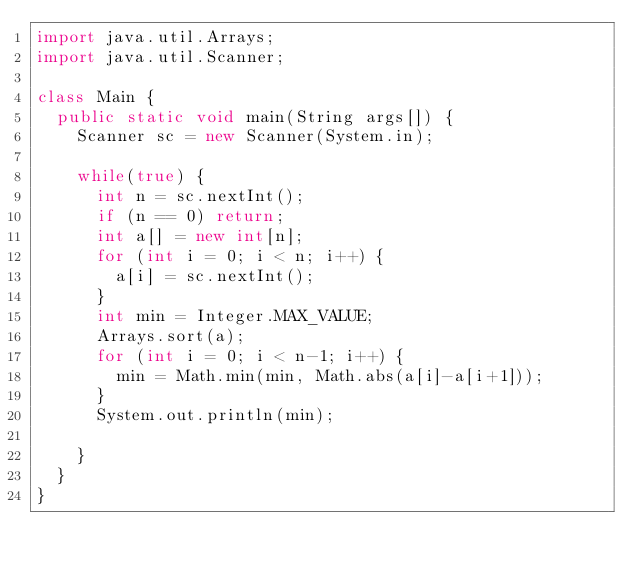<code> <loc_0><loc_0><loc_500><loc_500><_Java_>import java.util.Arrays;
import java.util.Scanner;

class Main {
	public static void main(String args[]) {
		Scanner sc = new Scanner(System.in);

		while(true) {
			int n = sc.nextInt();
			if (n == 0) return;
			int a[] = new int[n];
			for (int i = 0; i < n; i++) {
				a[i] = sc.nextInt();
			}
			int min = Integer.MAX_VALUE;
			Arrays.sort(a);
			for (int i = 0; i < n-1; i++) {
				min = Math.min(min, Math.abs(a[i]-a[i+1]));
			}
			System.out.println(min);

		}
	}
}
</code> 